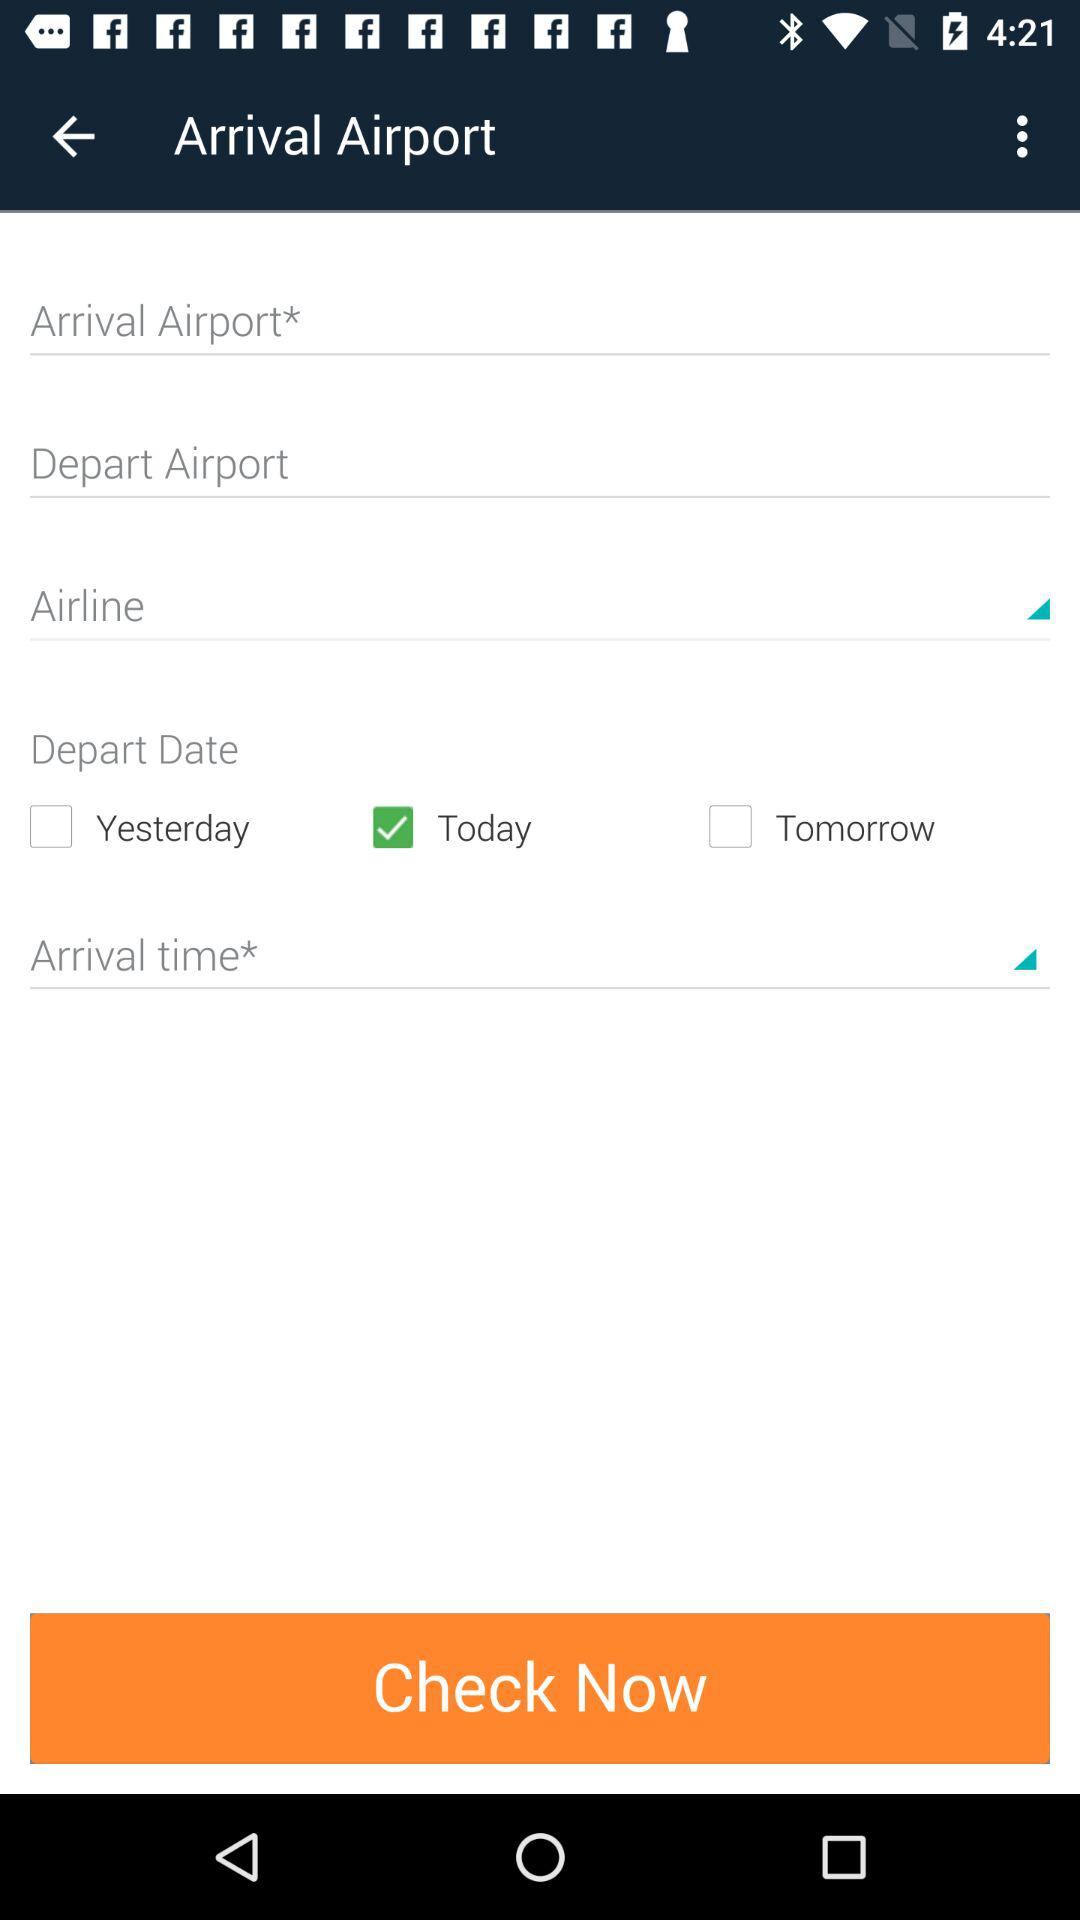What day is selected for departure? The day that is selected for departure is "Today". 